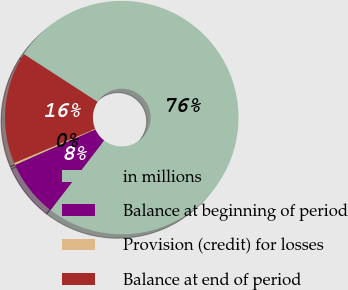Convert chart. <chart><loc_0><loc_0><loc_500><loc_500><pie_chart><fcel>in millions<fcel>Balance at beginning of period<fcel>Provision (credit) for losses<fcel>Balance at end of period<nl><fcel>76.29%<fcel>7.9%<fcel>0.3%<fcel>15.5%<nl></chart> 